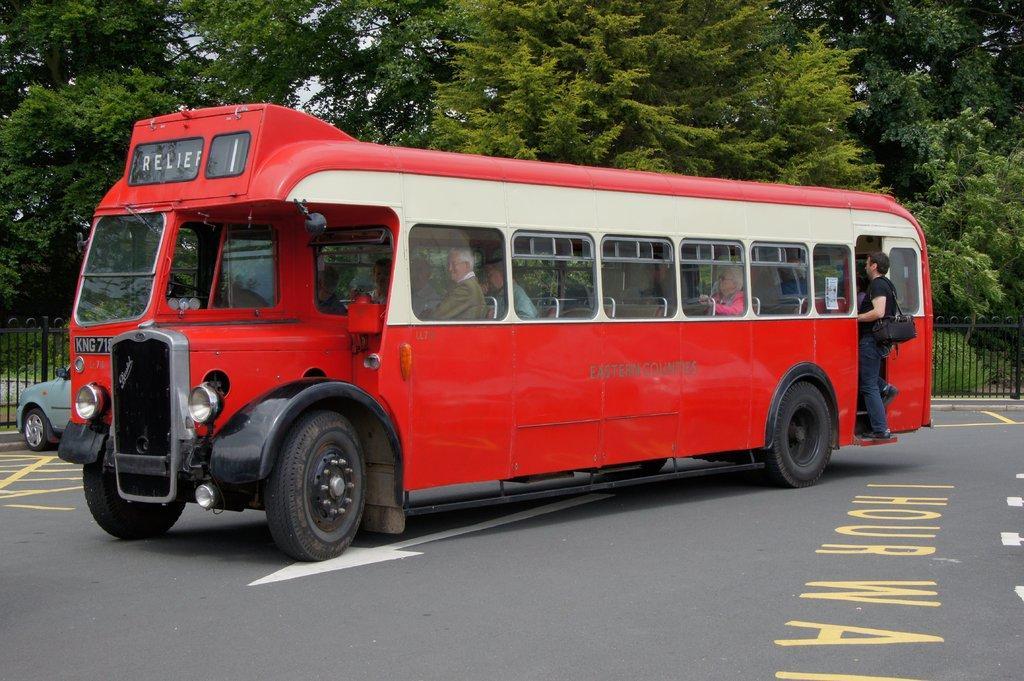Please provide a concise description of this image. In this image we can see a bus on the road. Inside the bus there are few people. In the back there is a car and railing. Also there are trees. 